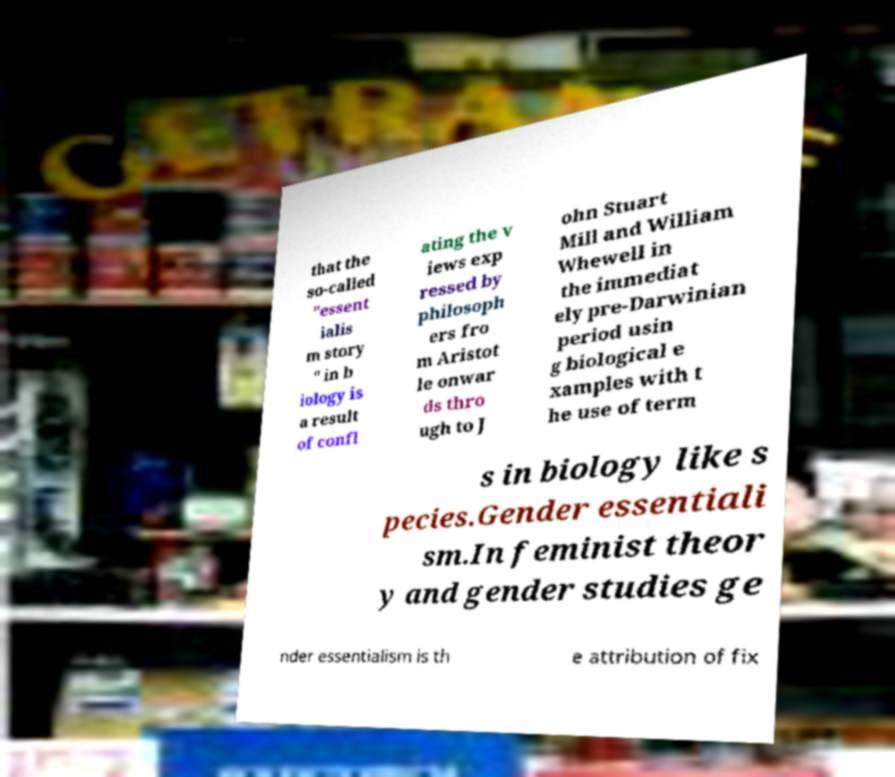For documentation purposes, I need the text within this image transcribed. Could you provide that? that the so-called "essent ialis m story " in b iology is a result of confl ating the v iews exp ressed by philosoph ers fro m Aristot le onwar ds thro ugh to J ohn Stuart Mill and William Whewell in the immediat ely pre-Darwinian period usin g biological e xamples with t he use of term s in biology like s pecies.Gender essentiali sm.In feminist theor y and gender studies ge nder essentialism is th e attribution of fix 